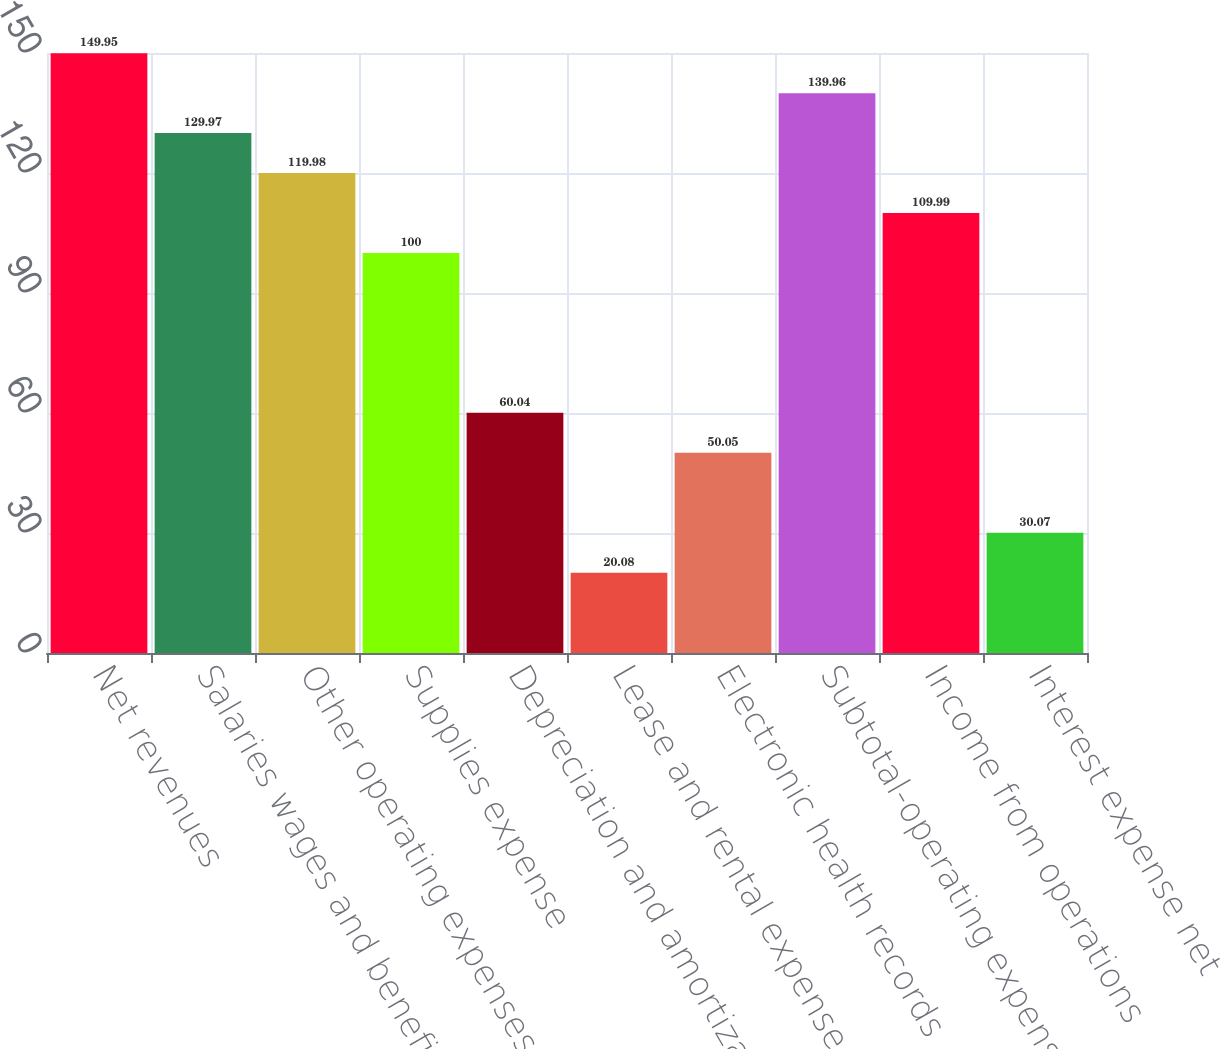Convert chart. <chart><loc_0><loc_0><loc_500><loc_500><bar_chart><fcel>Net revenues<fcel>Salaries wages and benefits<fcel>Other operating expenses<fcel>Supplies expense<fcel>Depreciation and amortization<fcel>Lease and rental expense<fcel>Electronic health records<fcel>Subtotal-operating expenses<fcel>Income from operations<fcel>Interest expense net<nl><fcel>149.95<fcel>129.97<fcel>119.98<fcel>100<fcel>60.04<fcel>20.08<fcel>50.05<fcel>139.96<fcel>109.99<fcel>30.07<nl></chart> 